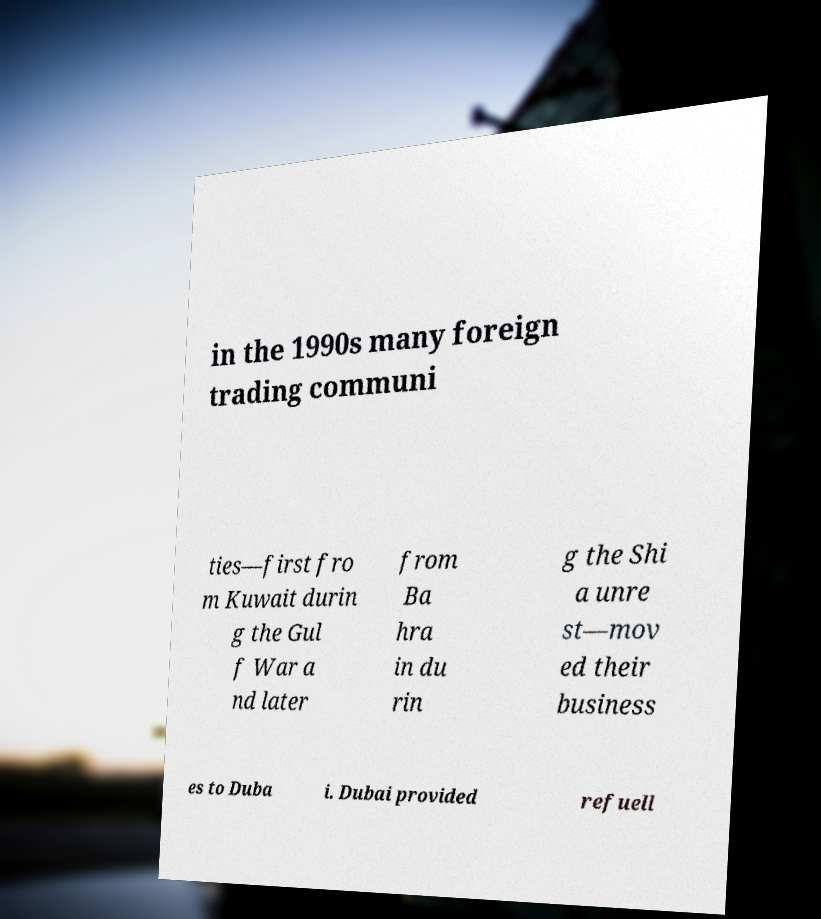Please read and relay the text visible in this image. What does it say? in the 1990s many foreign trading communi ties—first fro m Kuwait durin g the Gul f War a nd later from Ba hra in du rin g the Shi a unre st—mov ed their business es to Duba i. Dubai provided refuell 